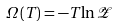<formula> <loc_0><loc_0><loc_500><loc_500>\Omega \left ( T \right ) = - T \ln \mathcal { Z }</formula> 